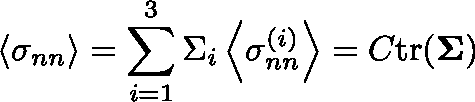<formula> <loc_0><loc_0><loc_500><loc_500>\left \langle \sigma _ { n n } \right \rangle = \sum _ { i = 1 } ^ { 3 } \Sigma _ { i } \left \langle \sigma _ { n n } ^ { ( i ) } \right \rangle = C t r ( \Sigma )</formula> 